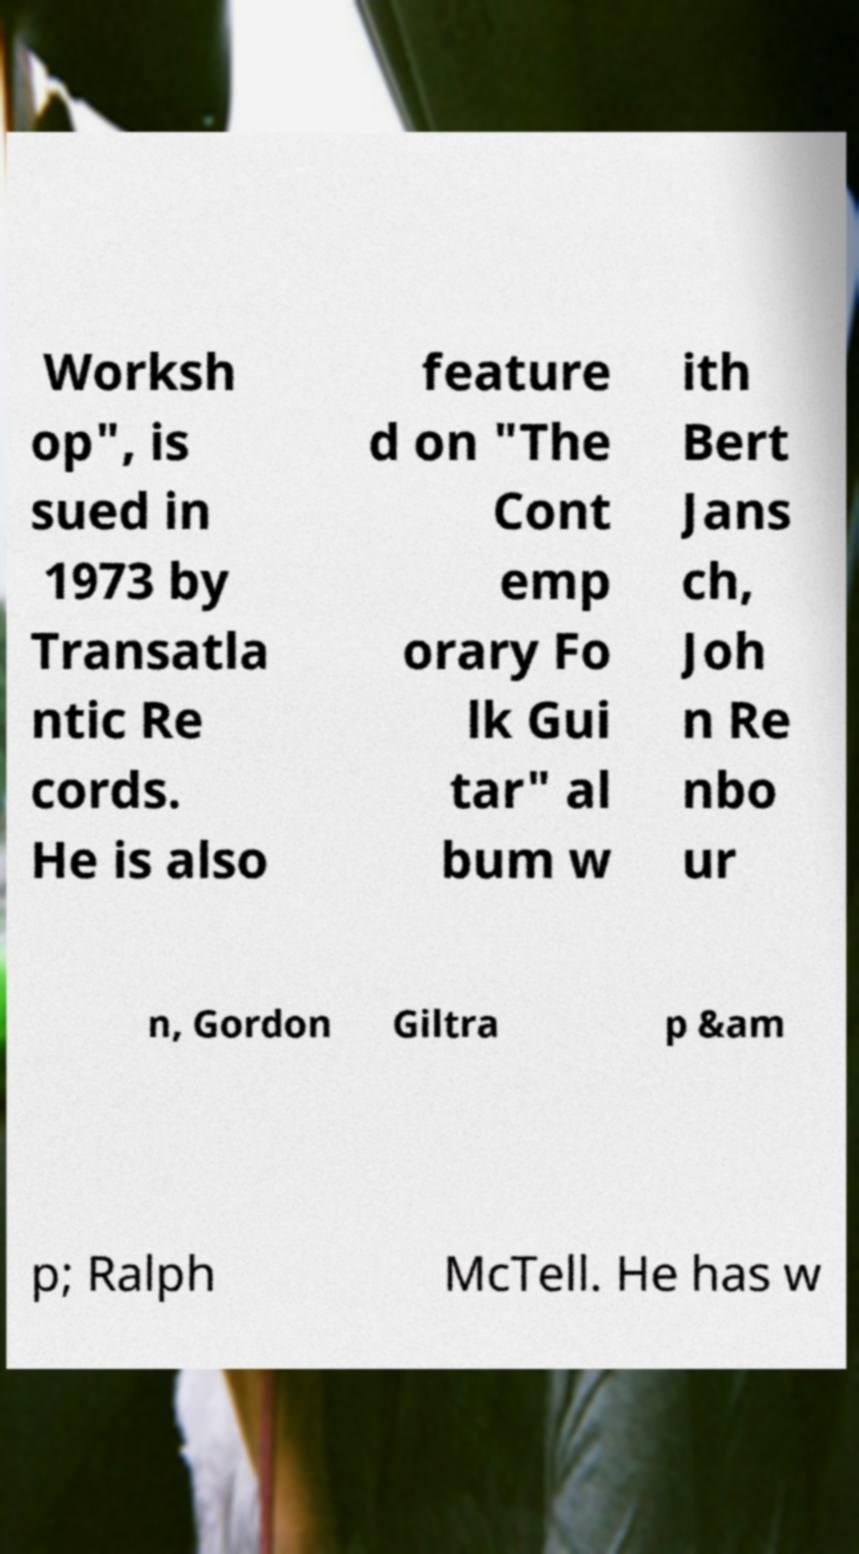For documentation purposes, I need the text within this image transcribed. Could you provide that? Worksh op", is sued in 1973 by Transatla ntic Re cords. He is also feature d on "The Cont emp orary Fo lk Gui tar" al bum w ith Bert Jans ch, Joh n Re nbo ur n, Gordon Giltra p &am p; Ralph McTell. He has w 